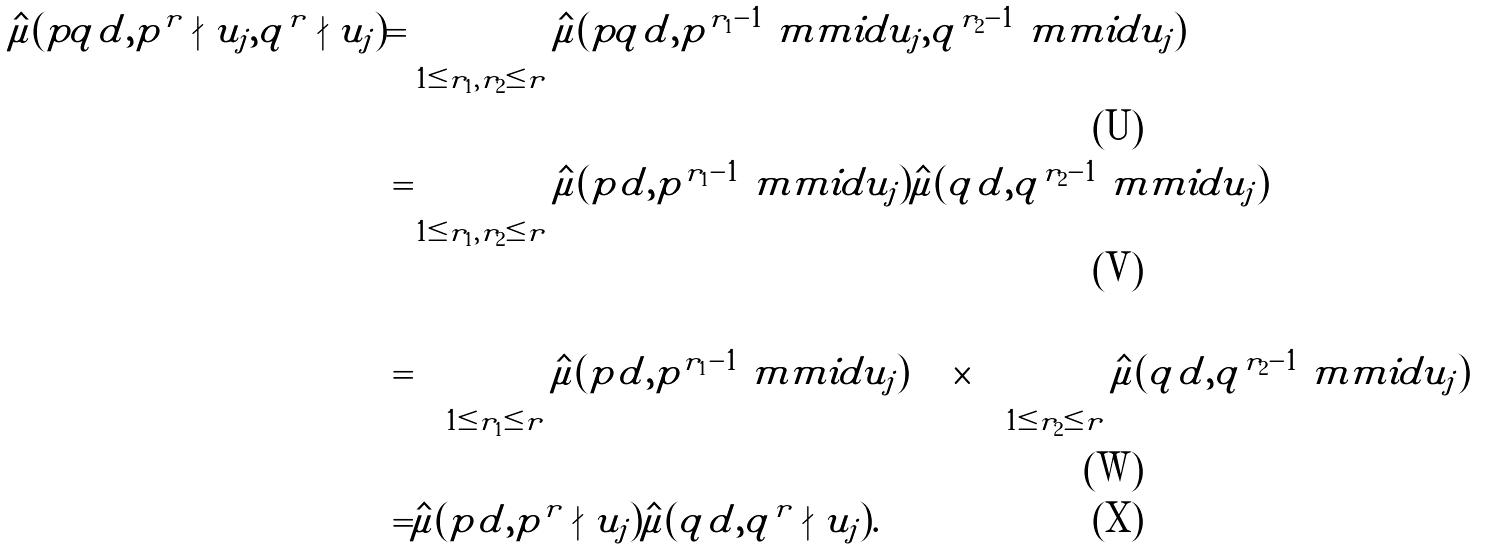<formula> <loc_0><loc_0><loc_500><loc_500>\hat { \mu } ( p q | d , p ^ { r } \nmid u _ { j } , q ^ { r } \nmid u _ { j } ) = & \sum _ { 1 \leq r _ { 1 } , r _ { 2 } \leq r } \hat { \mu } ( p q | d , p ^ { r _ { 1 } - 1 } \ m m i d u _ { j } , q ^ { r _ { 2 } - 1 } \ m m i d u _ { j } ) \\ = & \sum _ { 1 \leq r _ { 1 } , r _ { 2 } \leq r } \hat { \mu } ( p | d , p ^ { r _ { 1 } - 1 } \ m m i d u _ { j } ) \hat { \mu } ( q | d , q ^ { r _ { 2 } - 1 } \ m m i d u _ { j } ) \\ = & \left ( \sum _ { 1 \leq r _ { 1 } \leq r } \hat { \mu } ( p | d , p ^ { r _ { 1 } - 1 } \ m m i d u _ { j } ) \right ) \times \left ( \sum _ { 1 \leq r _ { 2 } \leq r } \hat { \mu } ( q | d , q ^ { r _ { 2 } - 1 } \ m m i d u _ { j } ) \right ) \\ = & \hat { \mu } ( p | d , p ^ { r } \nmid u _ { j } ) \hat { \mu } ( q | d , q ^ { r } \nmid u _ { j } ) .</formula> 